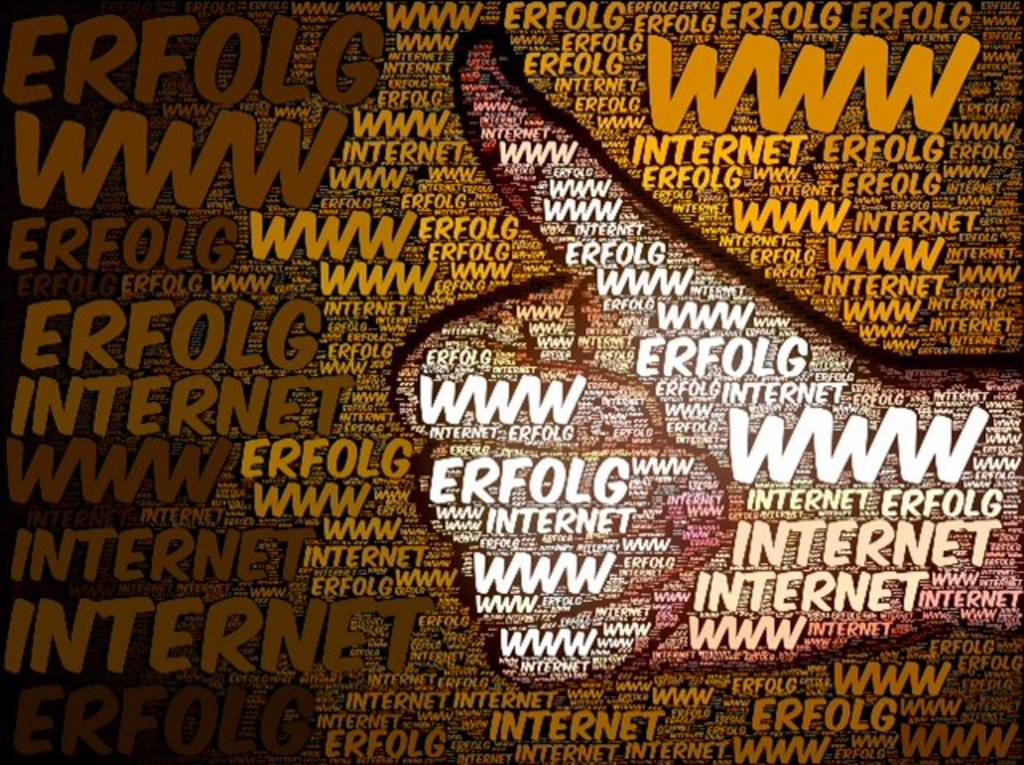Provide a one-sentence caption for the provided image. A letter mosaic of a thumbs up with the web address to erfolg internet. 